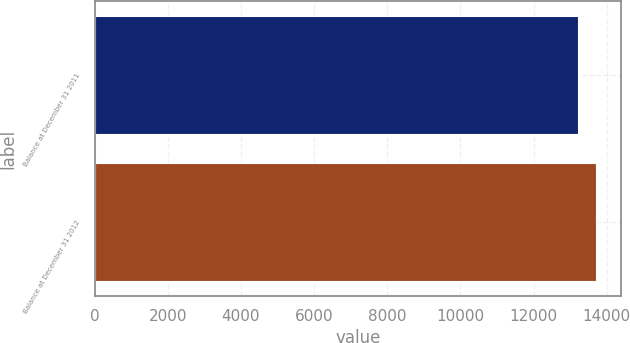Convert chart. <chart><loc_0><loc_0><loc_500><loc_500><bar_chart><fcel>Balance at December 31 2011<fcel>Balance at December 31 2012<nl><fcel>13201<fcel>13716<nl></chart> 